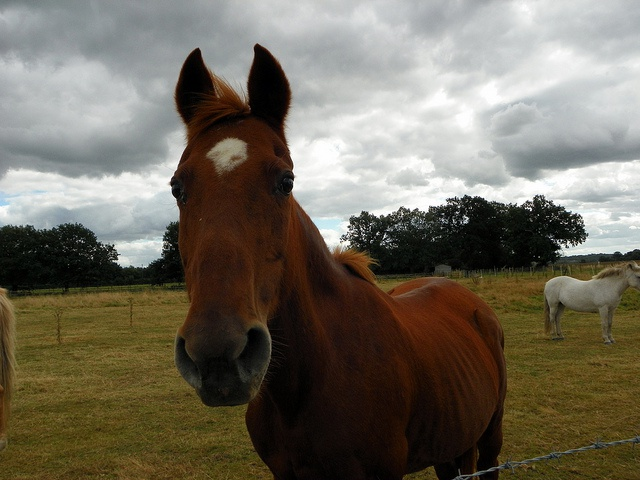Describe the objects in this image and their specific colors. I can see horse in gray, black, and maroon tones and horse in gray, darkgreen, and black tones in this image. 